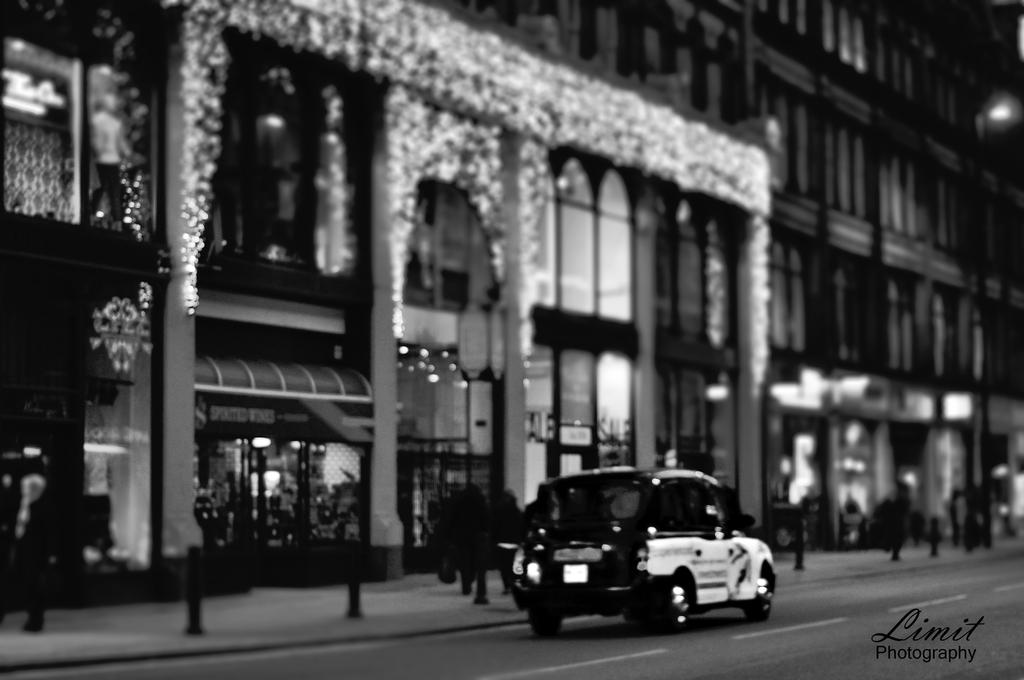What is the color scheme of the image? The image is black and white. What type of structures can be seen in the image? There are buildings in the image. What mode of transportation is present in the image? There is a car in the image. What are the vertical structures in the image? There are poles in the image. What type of path is visible in the image? There is a footpath in the image. What type of surface is designed for vehicles in the image? There is a road in the image. How can you touch the credit in the image? There is no credit present in the image, so it cannot be touched. 